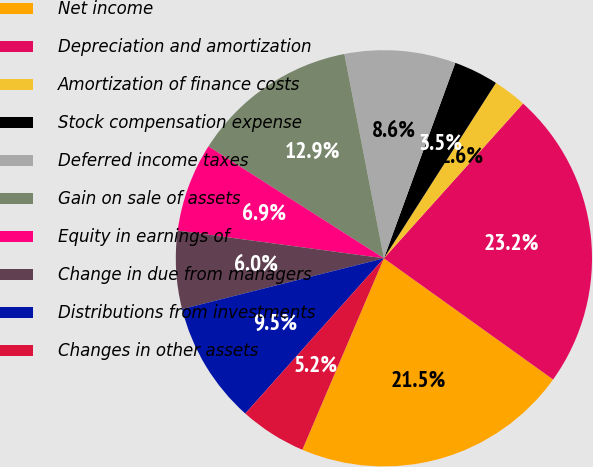Convert chart to OTSL. <chart><loc_0><loc_0><loc_500><loc_500><pie_chart><fcel>Net income<fcel>Depreciation and amortization<fcel>Amortization of finance costs<fcel>Stock compensation expense<fcel>Deferred income taxes<fcel>Gain on sale of assets<fcel>Equity in earnings of<fcel>Change in due from managers<fcel>Distributions from investments<fcel>Changes in other assets<nl><fcel>21.52%<fcel>23.24%<fcel>2.61%<fcel>3.47%<fcel>8.62%<fcel>12.92%<fcel>6.91%<fcel>6.05%<fcel>9.48%<fcel>5.19%<nl></chart> 